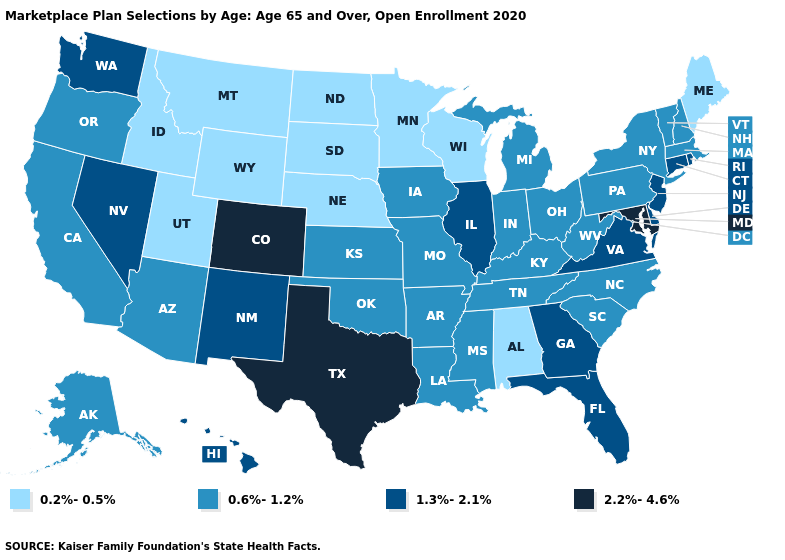Does the map have missing data?
Keep it brief. No. How many symbols are there in the legend?
Be succinct. 4. Does South Dakota have the lowest value in the USA?
Write a very short answer. Yes. Does North Dakota have the same value as Nebraska?
Keep it brief. Yes. Which states have the lowest value in the West?
Short answer required. Idaho, Montana, Utah, Wyoming. Name the states that have a value in the range 0.2%-0.5%?
Quick response, please. Alabama, Idaho, Maine, Minnesota, Montana, Nebraska, North Dakota, South Dakota, Utah, Wisconsin, Wyoming. Does Washington have the lowest value in the USA?
Give a very brief answer. No. What is the value of Ohio?
Short answer required. 0.6%-1.2%. Does Alabama have the highest value in the South?
Quick response, please. No. Does the first symbol in the legend represent the smallest category?
Keep it brief. Yes. How many symbols are there in the legend?
Quick response, please. 4. What is the value of Maryland?
Be succinct. 2.2%-4.6%. What is the value of Wisconsin?
Keep it brief. 0.2%-0.5%. Name the states that have a value in the range 1.3%-2.1%?
Short answer required. Connecticut, Delaware, Florida, Georgia, Hawaii, Illinois, Nevada, New Jersey, New Mexico, Rhode Island, Virginia, Washington. Which states have the lowest value in the West?
Concise answer only. Idaho, Montana, Utah, Wyoming. 